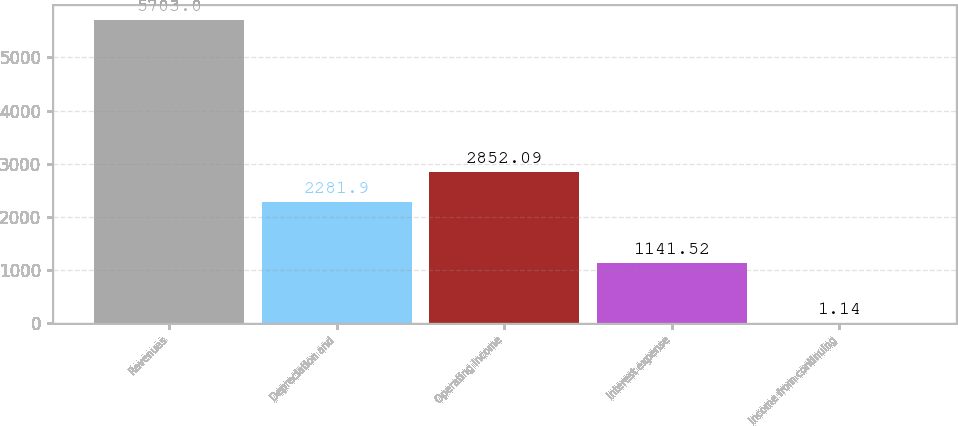Convert chart. <chart><loc_0><loc_0><loc_500><loc_500><bar_chart><fcel>Revenues<fcel>Depreciation and<fcel>Operating income<fcel>Interest expense<fcel>Income from continuing<nl><fcel>5703<fcel>2281.9<fcel>2852.09<fcel>1141.52<fcel>1.14<nl></chart> 